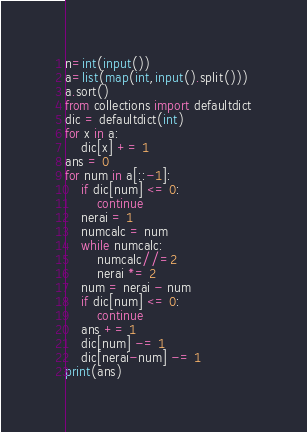<code> <loc_0><loc_0><loc_500><loc_500><_Python_>n=int(input())
a=list(map(int,input().split()))
a.sort()
from collections import defaultdict
dic = defaultdict(int)
for x in a:
    dic[x] += 1
ans = 0
for num in a[::-1]:
    if dic[num] <= 0:
        continue
    nerai = 1
    numcalc = num
    while numcalc:
        numcalc//=2
        nerai *= 2
    num = nerai - num
    if dic[num] <= 0:
        continue
    ans += 1
    dic[num] -= 1
    dic[nerai-num] -= 1
print(ans)</code> 